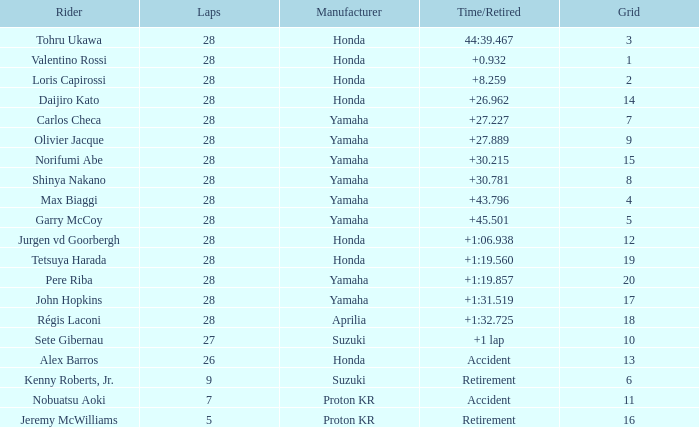Could you help me parse every detail presented in this table? {'header': ['Rider', 'Laps', 'Manufacturer', 'Time/Retired', 'Grid'], 'rows': [['Tohru Ukawa', '28', 'Honda', '44:39.467', '3'], ['Valentino Rossi', '28', 'Honda', '+0.932', '1'], ['Loris Capirossi', '28', 'Honda', '+8.259', '2'], ['Daijiro Kato', '28', 'Honda', '+26.962', '14'], ['Carlos Checa', '28', 'Yamaha', '+27.227', '7'], ['Olivier Jacque', '28', 'Yamaha', '+27.889', '9'], ['Norifumi Abe', '28', 'Yamaha', '+30.215', '15'], ['Shinya Nakano', '28', 'Yamaha', '+30.781', '8'], ['Max Biaggi', '28', 'Yamaha', '+43.796', '4'], ['Garry McCoy', '28', 'Yamaha', '+45.501', '5'], ['Jurgen vd Goorbergh', '28', 'Honda', '+1:06.938', '12'], ['Tetsuya Harada', '28', 'Honda', '+1:19.560', '19'], ['Pere Riba', '28', 'Yamaha', '+1:19.857', '20'], ['John Hopkins', '28', 'Yamaha', '+1:31.519', '17'], ['Régis Laconi', '28', 'Aprilia', '+1:32.725', '18'], ['Sete Gibernau', '27', 'Suzuki', '+1 lap', '10'], ['Alex Barros', '26', 'Honda', 'Accident', '13'], ['Kenny Roberts, Jr.', '9', 'Suzuki', 'Retirement', '6'], ['Nobuatsu Aoki', '7', 'Proton KR', 'Accident', '11'], ['Jeremy McWilliams', '5', 'Proton KR', 'Retirement', '16']]} How many laps did pere riba ride? 28.0. 